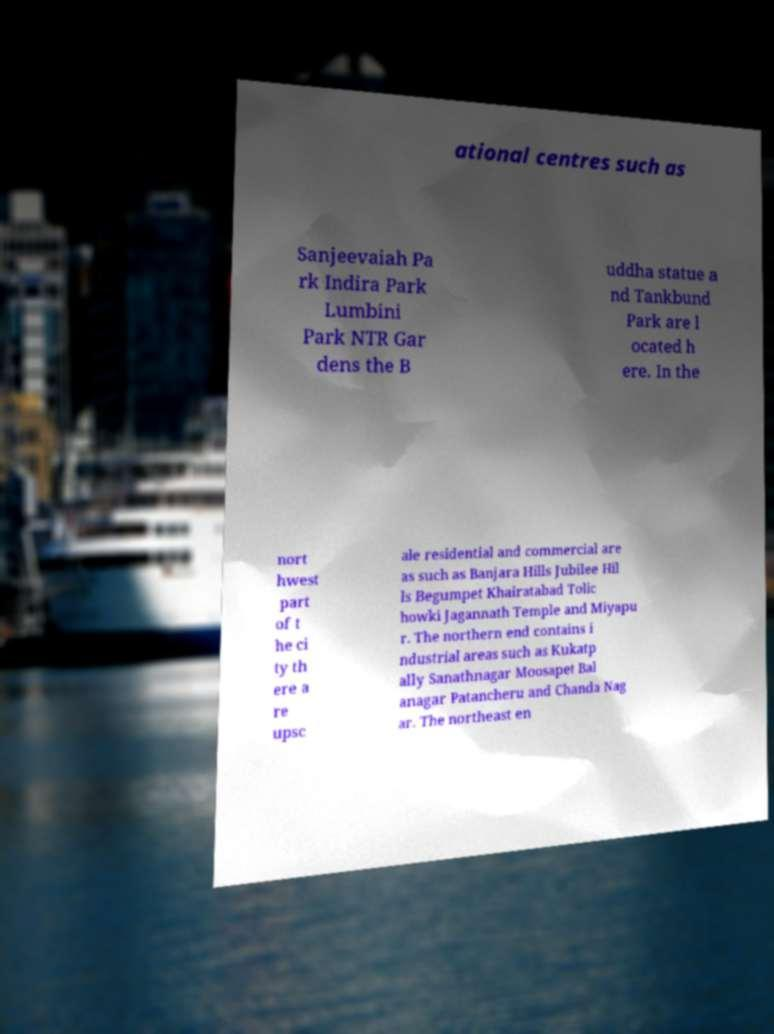Could you extract and type out the text from this image? ational centres such as Sanjeevaiah Pa rk Indira Park Lumbini Park NTR Gar dens the B uddha statue a nd Tankbund Park are l ocated h ere. In the nort hwest part of t he ci ty th ere a re upsc ale residential and commercial are as such as Banjara Hills Jubilee Hil ls Begumpet Khairatabad Tolic howki Jagannath Temple and Miyapu r. The northern end contains i ndustrial areas such as Kukatp ally Sanathnagar Moosapet Bal anagar Patancheru and Chanda Nag ar. The northeast en 